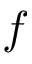Convert formula to latex. <formula><loc_0><loc_0><loc_500><loc_500>f</formula> 